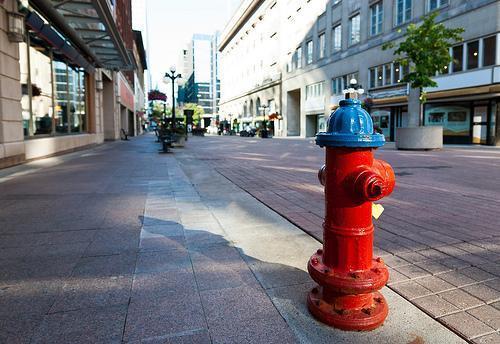How many fire hydrants?
Give a very brief answer. 1. 